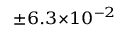<formula> <loc_0><loc_0><loc_500><loc_500>^ { \pm 6 . 3 \times 1 0 ^ { - 2 } }</formula> 